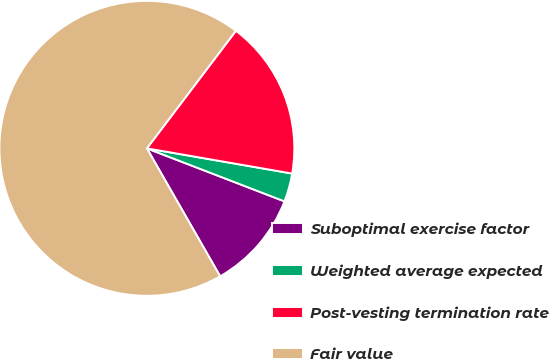Convert chart to OTSL. <chart><loc_0><loc_0><loc_500><loc_500><pie_chart><fcel>Suboptimal exercise factor<fcel>Weighted average expected<fcel>Post-vesting termination rate<fcel>Fair value<nl><fcel>10.87%<fcel>3.12%<fcel>17.42%<fcel>68.59%<nl></chart> 